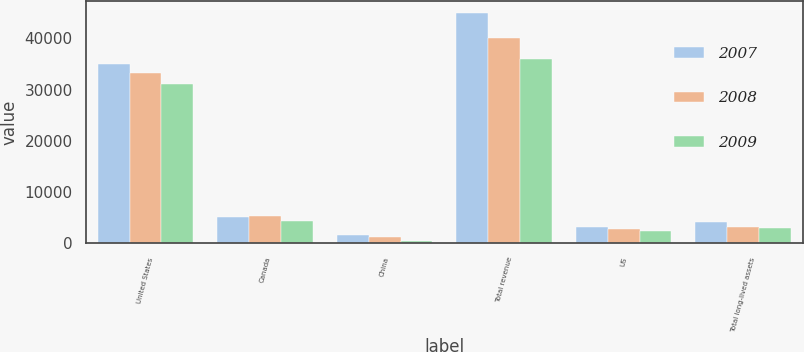<chart> <loc_0><loc_0><loc_500><loc_500><stacked_bar_chart><ecel><fcel>United States<fcel>Canada<fcel>China<fcel>Total revenue<fcel>US<fcel>Total long-lived assets<nl><fcel>2007<fcel>35070<fcel>5174<fcel>1558<fcel>45015<fcel>3155<fcel>4174<nl><fcel>2008<fcel>33328<fcel>5386<fcel>1309<fcel>40023<fcel>2733<fcel>3306<nl><fcel>2009<fcel>31031<fcel>4340<fcel>563<fcel>35934<fcel>2487<fcel>2938<nl></chart> 